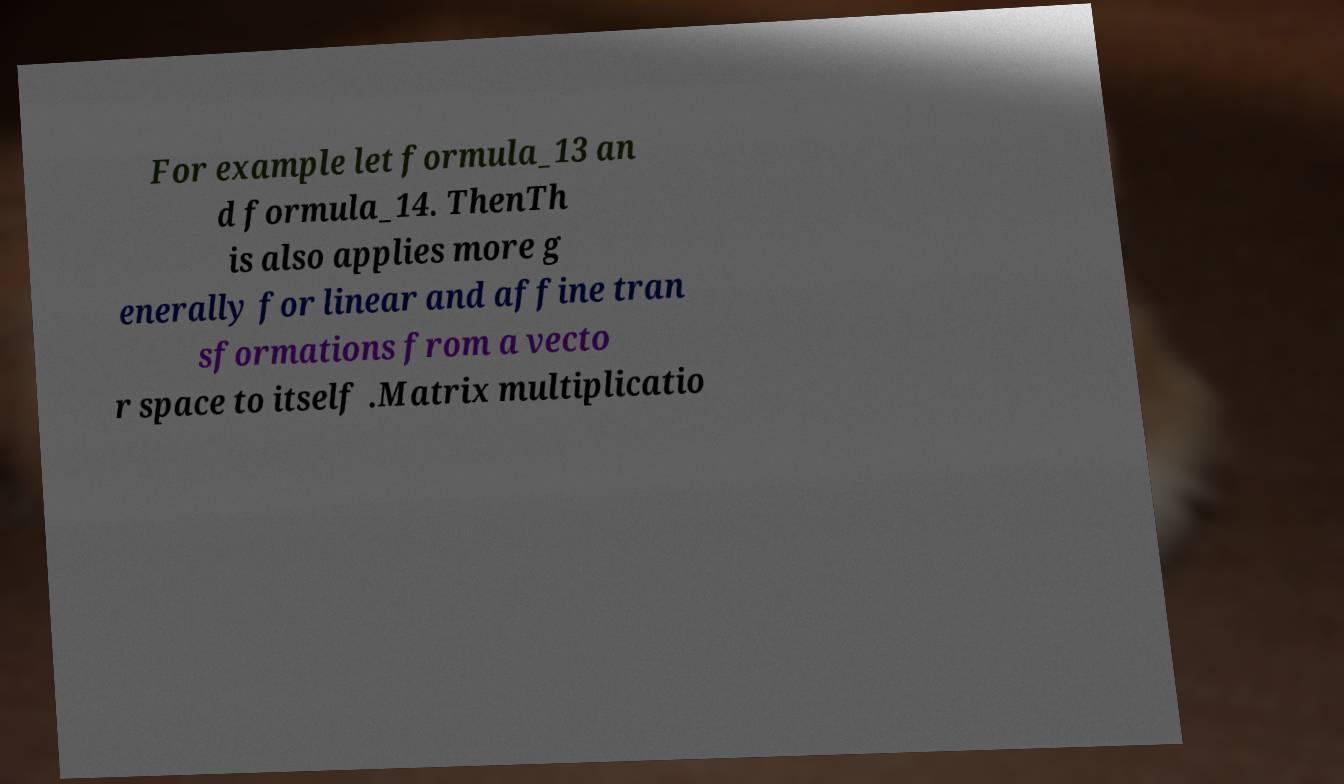Can you read and provide the text displayed in the image?This photo seems to have some interesting text. Can you extract and type it out for me? For example let formula_13 an d formula_14. ThenTh is also applies more g enerally for linear and affine tran sformations from a vecto r space to itself .Matrix multiplicatio 